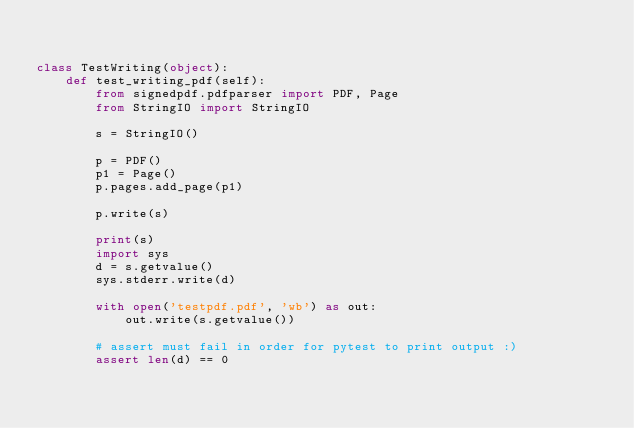Convert code to text. <code><loc_0><loc_0><loc_500><loc_500><_Python_>

class TestWriting(object):
    def test_writing_pdf(self):
        from signedpdf.pdfparser import PDF, Page
        from StringIO import StringIO

        s = StringIO()

        p = PDF()
        p1 = Page()
        p.pages.add_page(p1)

        p.write(s)

        print(s)
        import sys
        d = s.getvalue()
        sys.stderr.write(d)

        with open('testpdf.pdf', 'wb') as out:
            out.write(s.getvalue())

        # assert must fail in order for pytest to print output :)
        assert len(d) == 0</code> 